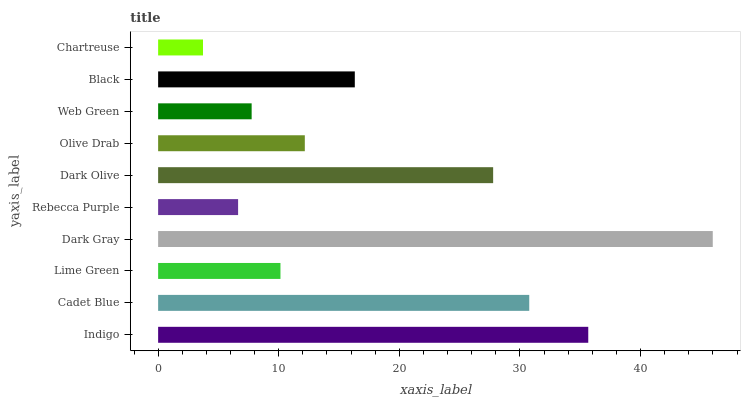Is Chartreuse the minimum?
Answer yes or no. Yes. Is Dark Gray the maximum?
Answer yes or no. Yes. Is Cadet Blue the minimum?
Answer yes or no. No. Is Cadet Blue the maximum?
Answer yes or no. No. Is Indigo greater than Cadet Blue?
Answer yes or no. Yes. Is Cadet Blue less than Indigo?
Answer yes or no. Yes. Is Cadet Blue greater than Indigo?
Answer yes or no. No. Is Indigo less than Cadet Blue?
Answer yes or no. No. Is Black the high median?
Answer yes or no. Yes. Is Olive Drab the low median?
Answer yes or no. Yes. Is Olive Drab the high median?
Answer yes or no. No. Is Cadet Blue the low median?
Answer yes or no. No. 